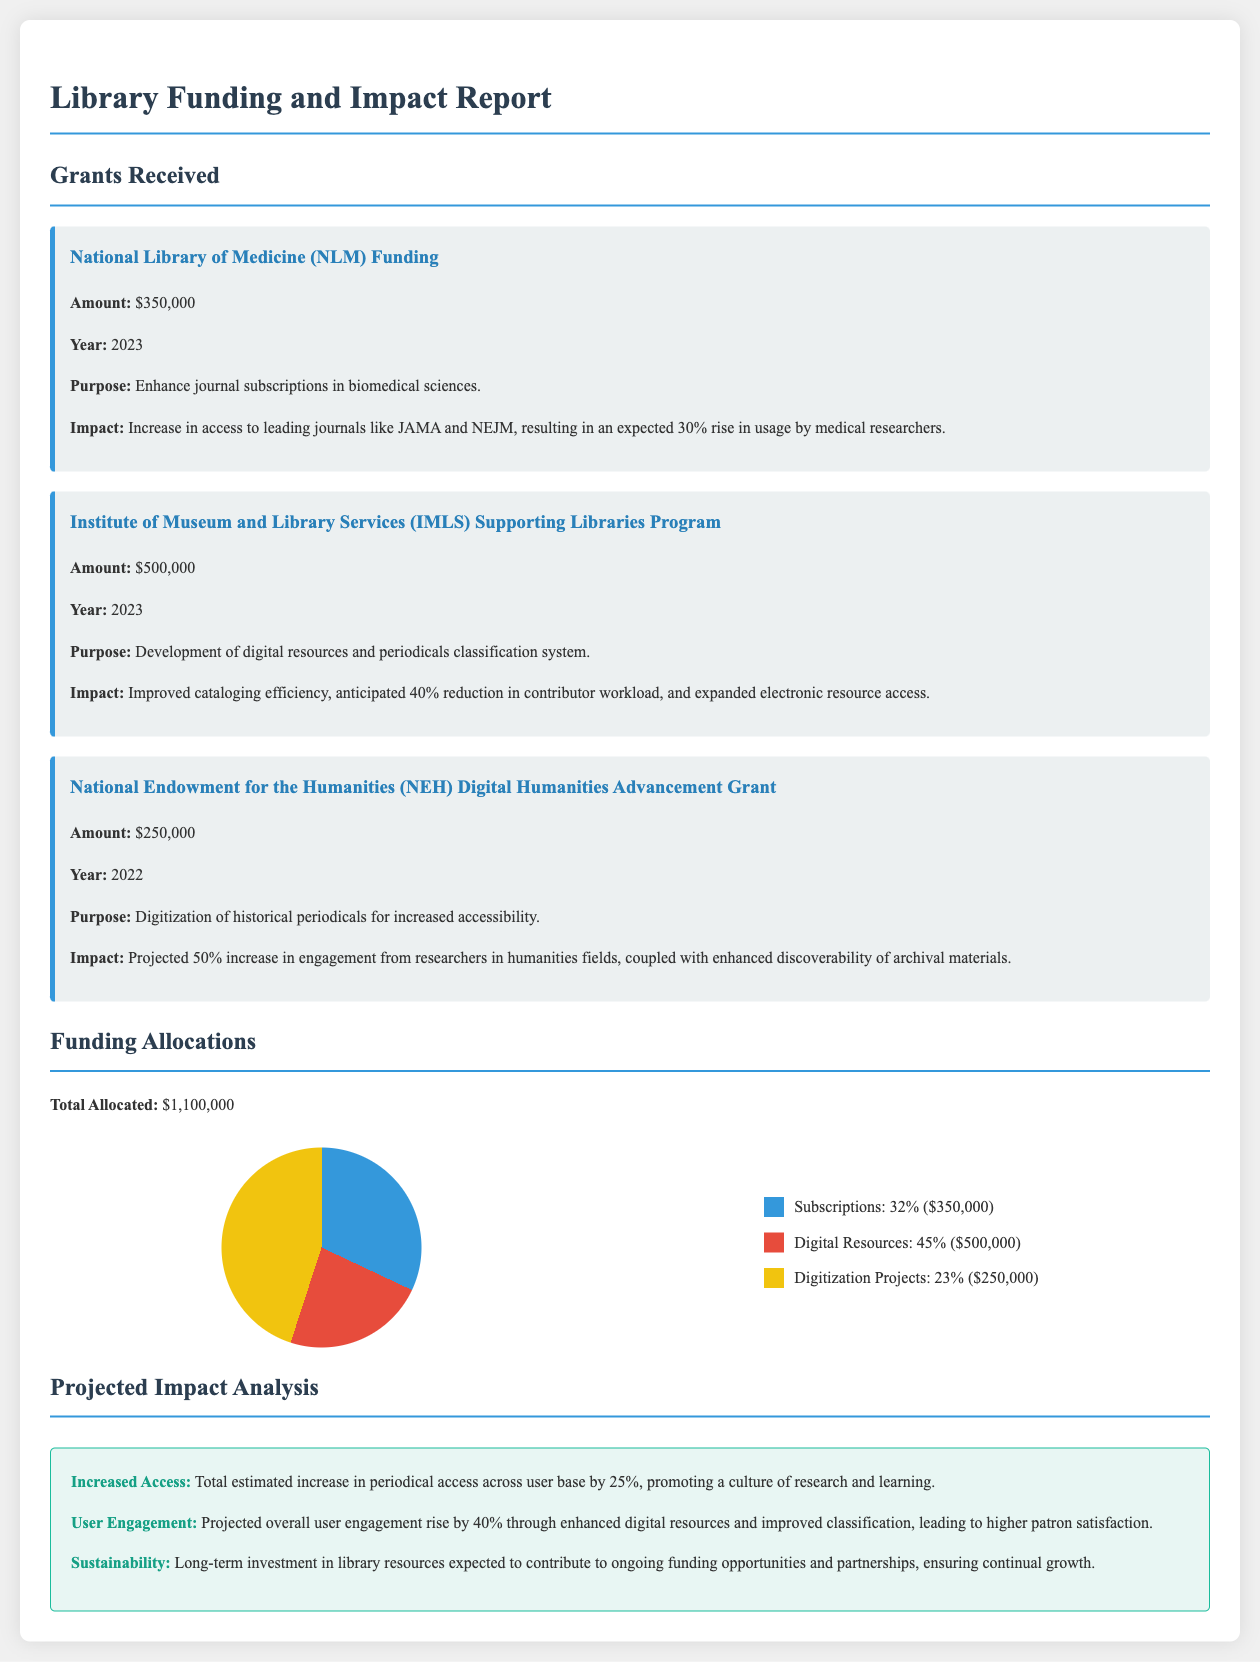What is the amount received from the National Library of Medicine? The amount received from the National Library of Medicine is specified in the report, which is $350,000.
Answer: $350,000 What is the purpose of the IMLS Supporting Libraries Program grant? The report states that the purpose of the IMLS Supporting Libraries Program grant is the development of digital resources and periodicals classification system.
Answer: Development of digital resources and periodicals classification system What is the projected increase in access to periodicals from the NEH grant? The projected increase in access to periodicals from the NEH grant is detailed in the report as a 50% increase.
Answer: 50% What percentage of the total funding is allocated for digital resources? The report indicates that 45% of the total funding is allocated for digital resources.
Answer: 45% What is the total allocated funding amount? The total allocated funding amount is clearly outlined in the report as $1,100,000.
Answer: $1,100,000 What is the expected rise in user engagement due to enhancements in digital resources? The expected rise in user engagement is mentioned in the document, which indicates a 40% increase.
Answer: 40% What percentage of the total funding is earmarked for subscriptions? According to the report, 32% of the total funding is designated for subscriptions.
Answer: 32% What impact is expected from enhanced journal subscriptions in biomedical sciences? The report projects that enhanced journal subscriptions in biomedical sciences will result in an expected 30% rise in usage by medical researchers.
Answer: 30% What is a potential long-term impact of the funding on library resources? The report mentions that there is an expectation for ongoing funding opportunities and partnerships, ensuring continual growth.
Answer: Ongoing funding opportunities and partnerships 